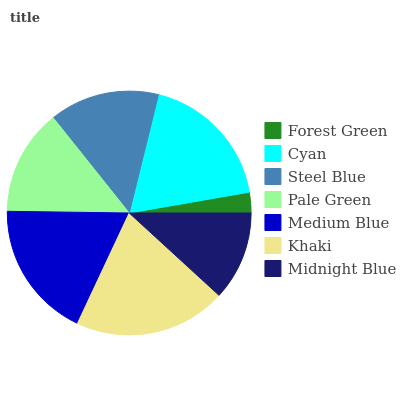Is Forest Green the minimum?
Answer yes or no. Yes. Is Khaki the maximum?
Answer yes or no. Yes. Is Cyan the minimum?
Answer yes or no. No. Is Cyan the maximum?
Answer yes or no. No. Is Cyan greater than Forest Green?
Answer yes or no. Yes. Is Forest Green less than Cyan?
Answer yes or no. Yes. Is Forest Green greater than Cyan?
Answer yes or no. No. Is Cyan less than Forest Green?
Answer yes or no. No. Is Steel Blue the high median?
Answer yes or no. Yes. Is Steel Blue the low median?
Answer yes or no. Yes. Is Khaki the high median?
Answer yes or no. No. Is Forest Green the low median?
Answer yes or no. No. 